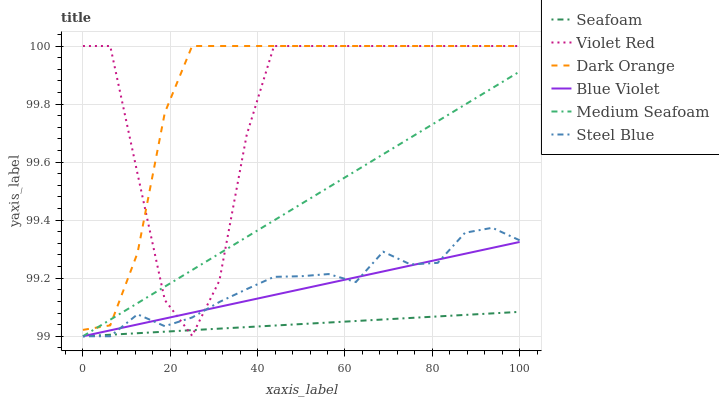Does Seafoam have the minimum area under the curve?
Answer yes or no. Yes. Does Dark Orange have the maximum area under the curve?
Answer yes or no. Yes. Does Violet Red have the minimum area under the curve?
Answer yes or no. No. Does Violet Red have the maximum area under the curve?
Answer yes or no. No. Is Blue Violet the smoothest?
Answer yes or no. Yes. Is Violet Red the roughest?
Answer yes or no. Yes. Is Steel Blue the smoothest?
Answer yes or no. No. Is Steel Blue the roughest?
Answer yes or no. No. Does Steel Blue have the lowest value?
Answer yes or no. Yes. Does Violet Red have the lowest value?
Answer yes or no. No. Does Violet Red have the highest value?
Answer yes or no. Yes. Does Steel Blue have the highest value?
Answer yes or no. No. Is Blue Violet less than Dark Orange?
Answer yes or no. Yes. Is Dark Orange greater than Steel Blue?
Answer yes or no. Yes. Does Blue Violet intersect Seafoam?
Answer yes or no. Yes. Is Blue Violet less than Seafoam?
Answer yes or no. No. Is Blue Violet greater than Seafoam?
Answer yes or no. No. Does Blue Violet intersect Dark Orange?
Answer yes or no. No. 